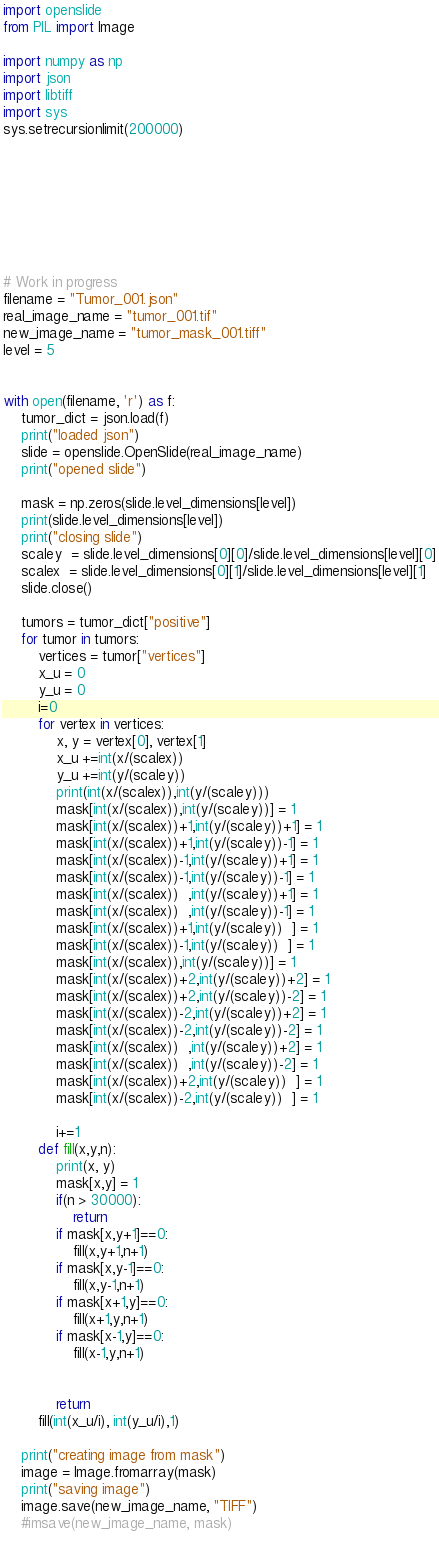Convert code to text. <code><loc_0><loc_0><loc_500><loc_500><_Python_>import openslide
from PIL import Image

import numpy as np
import json
import libtiff
import sys
sys.setrecursionlimit(200000)








# Work in progress
filename = "Tumor_001.json"
real_image_name = "tumor_001.tif"
new_image_name = "tumor_mask_001.tiff"
level = 5


with open(filename, 'r') as f:
    tumor_dict = json.load(f)
    print("loaded json")
    slide = openslide.OpenSlide(real_image_name)
    print("opened slide")

    mask = np.zeros(slide.level_dimensions[level])
    print(slide.level_dimensions[level])
    print("closing slide")
    scaley  = slide.level_dimensions[0][0]/slide.level_dimensions[level][0]
    scalex  = slide.level_dimensions[0][1]/slide.level_dimensions[level][1]
    slide.close()

    tumors = tumor_dict["positive"]
    for tumor in tumors:
        vertices = tumor["vertices"]
        x_u = 0
        y_u = 0
        i=0
        for vertex in vertices:
            x, y = vertex[0], vertex[1]
            x_u +=int(x/(scalex))
            y_u +=int(y/(scaley))
            print(int(x/(scalex)),int(y/(scaley)))
            mask[int(x/(scalex)),int(y/(scaley))] = 1
            mask[int(x/(scalex))+1,int(y/(scaley))+1] = 1
            mask[int(x/(scalex))+1,int(y/(scaley))-1] = 1
            mask[int(x/(scalex))-1,int(y/(scaley))+1] = 1
            mask[int(x/(scalex))-1,int(y/(scaley))-1] = 1
            mask[int(x/(scalex))  ,int(y/(scaley))+1] = 1
            mask[int(x/(scalex))  ,int(y/(scaley))-1] = 1
            mask[int(x/(scalex))+1,int(y/(scaley))  ] = 1
            mask[int(x/(scalex))-1,int(y/(scaley))  ] = 1
            mask[int(x/(scalex)),int(y/(scaley))] = 1
            mask[int(x/(scalex))+2,int(y/(scaley))+2] = 1
            mask[int(x/(scalex))+2,int(y/(scaley))-2] = 1
            mask[int(x/(scalex))-2,int(y/(scaley))+2] = 1
            mask[int(x/(scalex))-2,int(y/(scaley))-2] = 1
            mask[int(x/(scalex))  ,int(y/(scaley))+2] = 1
            mask[int(x/(scalex))  ,int(y/(scaley))-2] = 1
            mask[int(x/(scalex))+2,int(y/(scaley))  ] = 1
            mask[int(x/(scalex))-2,int(y/(scaley))  ] = 1

            i+=1
        def fill(x,y,n):
            print(x, y)
            mask[x,y] = 1
            if(n > 30000):
                return
            if mask[x,y+1]==0:
                fill(x,y+1,n+1)
            if mask[x,y-1]==0:
                fill(x,y-1,n+1)
            if mask[x+1,y]==0:
                fill(x+1,y,n+1)
            if mask[x-1,y]==0:
                fill(x-1,y,n+1)


            return
        fill(int(x_u/i), int(y_u/i),1)

    print("creating image from mask")
    image = Image.fromarray(mask)
    print("saving image")
    image.save(new_image_name, "TIFF")
    #imsave(new_image_name, mask)
    
</code> 